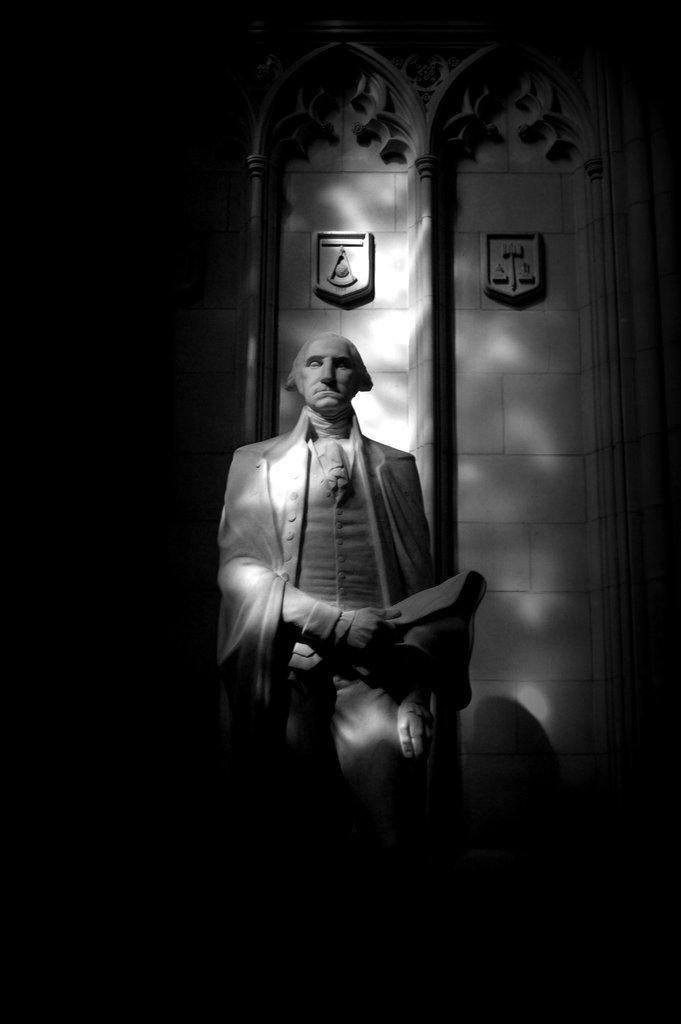What is the color scheme of the image? The image is black and white. What is the main subject in the image? There is a statue in the image. Where is the statue located in relation to other objects or structures? The statue is in front of a wall. What type of zinc is used to create the statue in the image? There is no mention of zinc being used to create the statue in the image, nor is there any indication of the material used. 